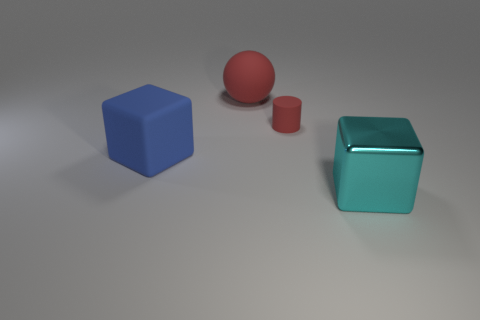Subtract all blue cubes. How many cubes are left? 1 Add 2 large blue metal objects. How many objects exist? 6 Subtract 1 balls. How many balls are left? 0 Subtract all brown balls. How many gray cylinders are left? 0 Subtract all big brown blocks. Subtract all tiny red rubber objects. How many objects are left? 3 Add 1 red objects. How many red objects are left? 3 Add 4 big blue rubber cubes. How many big blue rubber cubes exist? 5 Subtract 0 green cylinders. How many objects are left? 4 Subtract all blue cubes. Subtract all gray cylinders. How many cubes are left? 1 